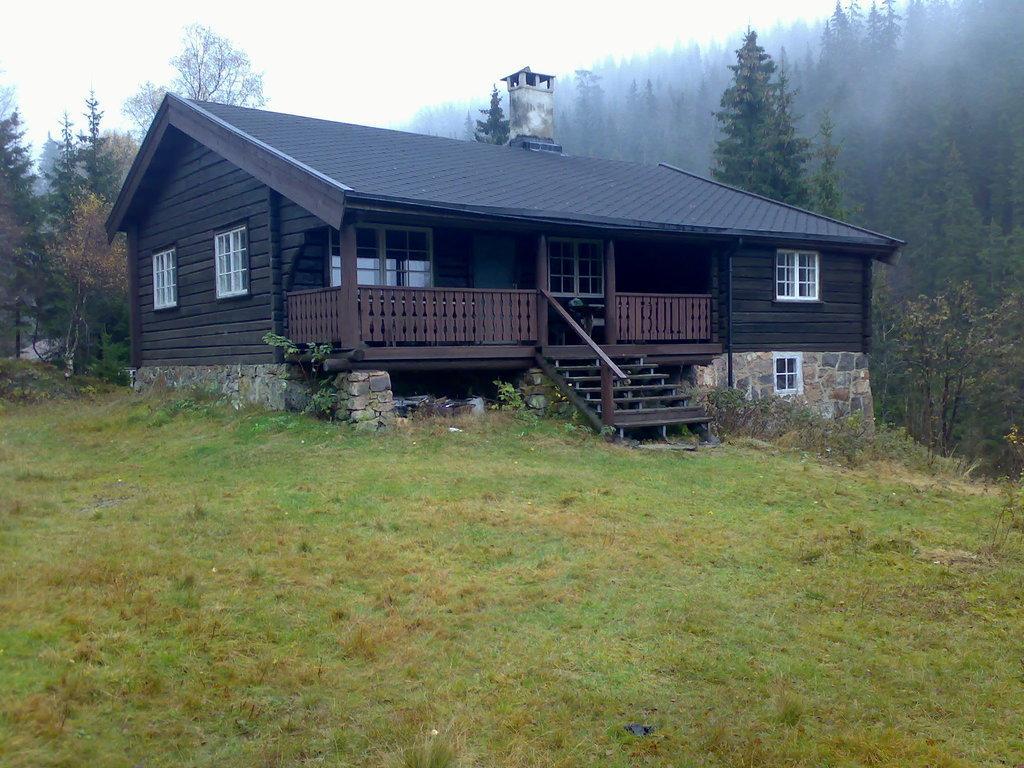Can you describe this image briefly? In this image, this looks like a house with the windows and stairs. I can see the grass. In the background, these are the trees with branches and leaves. 